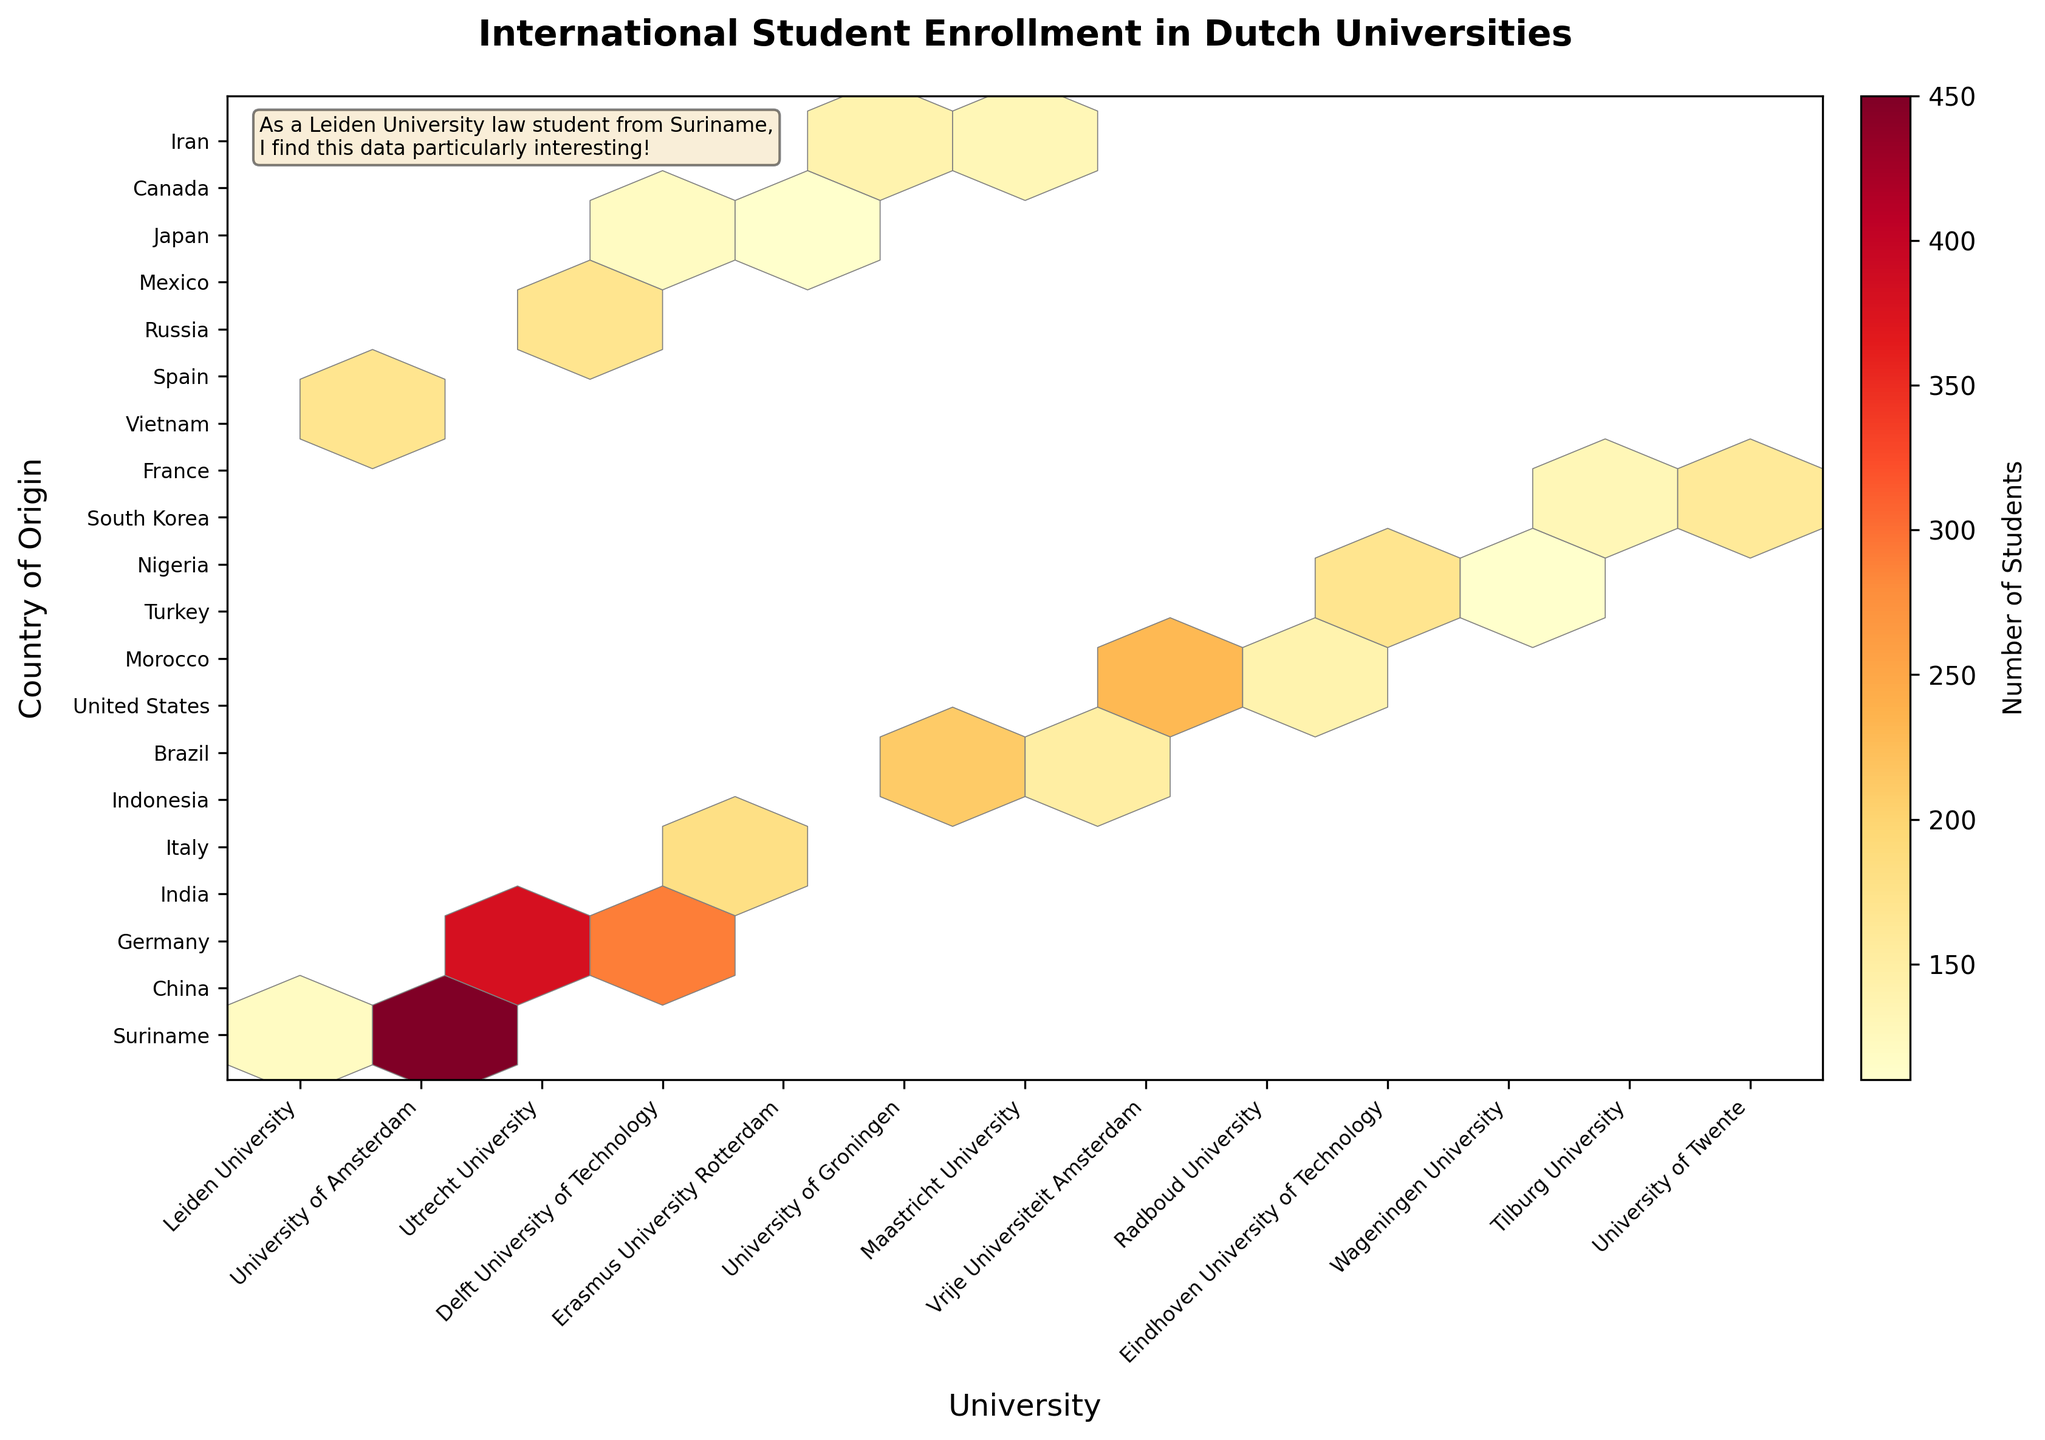What is the title of this hexbin plot? The title of a plot is usually located at the top center and describes the content of the plot. Here, the title is "International Student Enrollment in Dutch Universities".
Answer: International Student Enrollment in Dutch Universities Which university has the highest number of students from China? To find the university with the highest number of students from China, locate the hexbin corresponding to China on the y-axis and check the color intensity. The University of Amsterdam has the brightest color, indicating they have the highest number of students from China.
Answer: University of Amsterdam How many students from Suriname are enrolled at Leiden University? Locate the hexbin for Suriname on the y-axis and Leiden University on the x-axis. The color intensity and associated colorbar indicate the number of students.
Answer: 120 Which country has the least number of students at the University of Groningen? Find the University of Groningen on the x-axis and check each hexbin's color intensity for all countries listed on the y-axis. The hexbin with the lowest color intensity indicates the country with the least number of students.
Answer: Indonesia Between Erasmus University Rotterdam and Maastricht University, which one has more students from Brazil? Compare the color intensity of the hexbin for Brazil (y-axis) for both Erasmus University Rotterdam and Maastricht University (x-axis). The university with the more intense color has more students.
Answer: Maastricht University How does the student enrollment from Vietnam at Leiden University compare to student enrollment from South Korea at Tilburg University? Compare the color intensity of the hexbin for Vietnam at Leiden University with that of South Korea at Tilburg University. The hexbin for Vietnam at Leiden University is more intense than for South Korea at Tilburg University.
Answer: Vietnam at Leiden University has higher What is the average number of students from Brazil across all universities? Identify all the hexbin colors for Brazil across each university and use the colorbar to find the corresponding number of students for each hexbin. Add these numbers and divide by the number of universities.
Answer: 150 (Only Maastricht University) Which university has the second highest number of international students from India? Compare the color of the hexbin representing students from India at different universities. As higher color intensity generally denotes more students, find the one with slightly lower intensity than the highest.
Answer: Not discernible (only Delft University of Technology in the list) Which country has the most diverse university enrollment in terms of the number of schools attended? Compare the countries by counting the number of different universities each country is represented in. The country with the most number of universities denotes the highest diversity.
Answer: China 